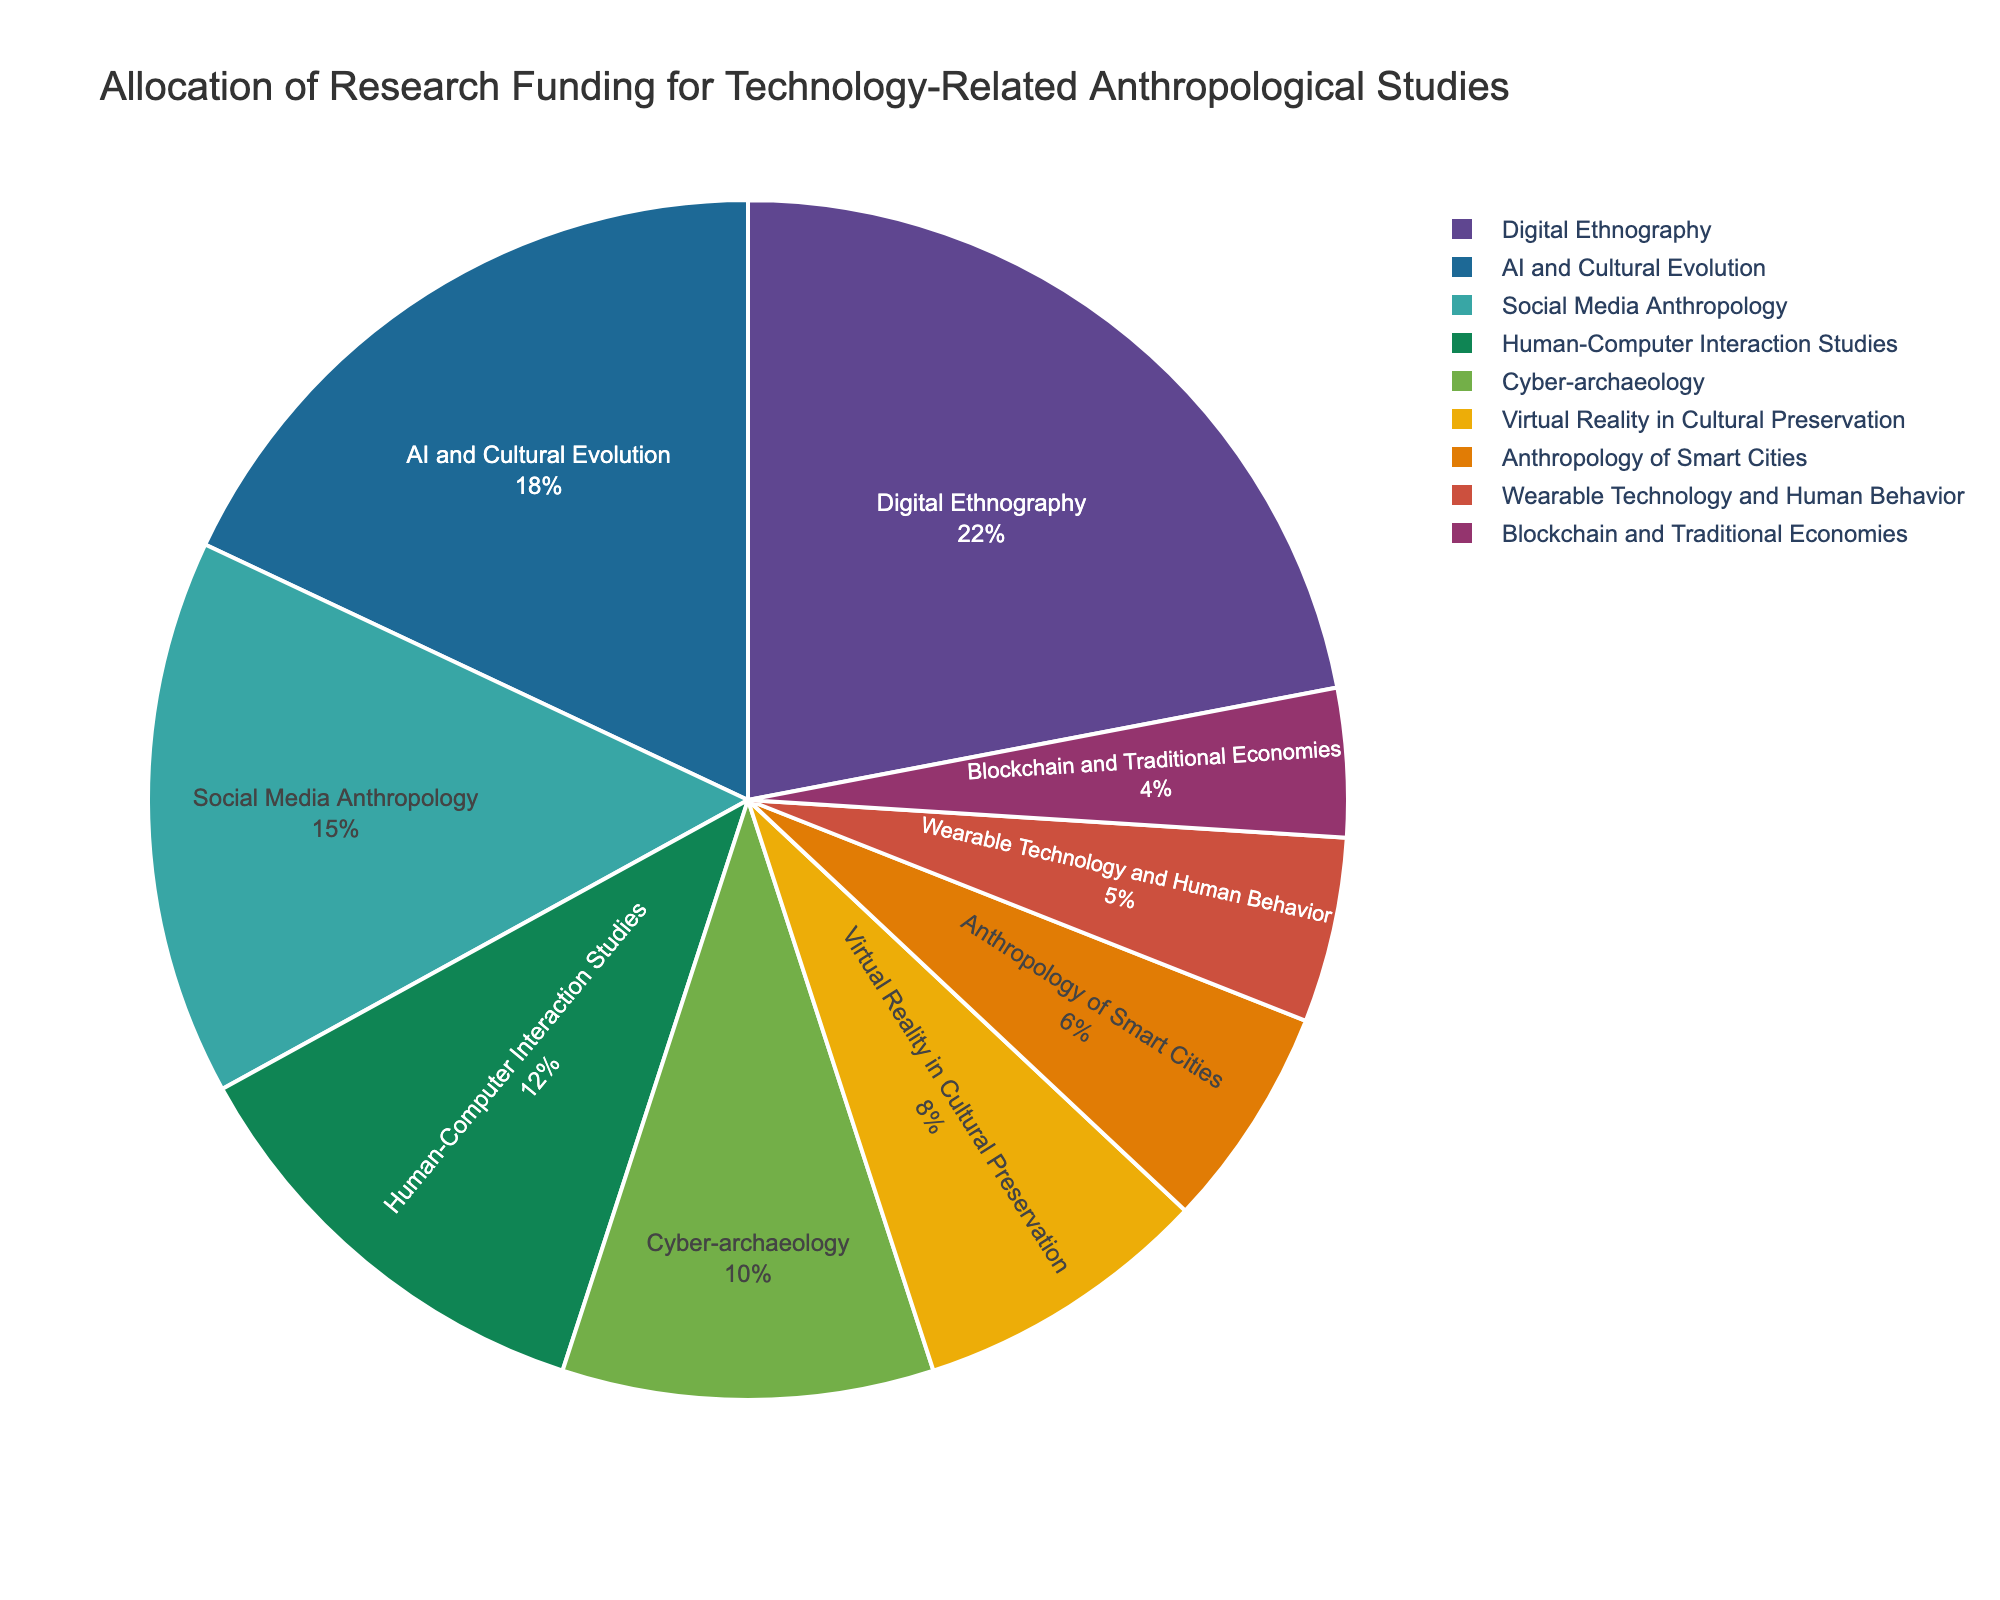What's the combined funding percentage for AI and Cultural Evolution, and Cyber-archaeology? First, identify the funding percentages for AI and Cultural Evolution (18%) and Cyber-archaeology (10%). Then sum these values: 18 + 10 = 28.
Answer: 28 Which research area received less funding, Wearable Technology and Human Behavior, or Blockchain and Traditional Economies? Wearable Technology and Human Behavior received 5%, while Blockchain and Traditional Economies received 4%. Since 4% is less than 5%, Blockchain and Traditional Economies received less funding.
Answer: Blockchain and Traditional Economies What is the difference in funding percentage between Social Media Anthropology and Human-Computer Interaction Studies? Social Media Anthropology received 15%, and Human-Computer Interaction Studies received 12%. The difference is 15 - 12 = 3.
Answer: 3 What is the average funding percentage for Digital Ethnography, Virtual Reality in Cultural Preservation, and Anthropology of Smart Cities? First, sum the percentages for these areas: Digital Ethnography (22%), Virtual Reality in Cultural Preservation (8%), and Anthropology of Smart Cities (6%). 22 + 8 + 6 = 36. Then, divide by the number of areas: 36 / 3 = 12.
Answer: 12 What are the top three research areas receiving the most funding? The percentages show that the top three areas are Digital Ethnography (22%), AI and Cultural Evolution (18%), and Social Media Anthropology (15%).
Answer: Digital Ethnography, AI and Cultural Evolution, Social Media Anthropology How much more funding does Digital Ethnography receive than Virtual Reality in Cultural Preservation? Digital Ethnography receives 22%, Virtual Reality in Cultural Preservation receives 8%. The difference is 22 - 8 = 14.
Answer: 14 Which research area receives the highest funding? From the chart, Digital Ethnography has the highest funding percentage at 22%.
Answer: Digital Ethnography Are any research areas allocated exactly 10% of the funding? Cyber-archaeology is allocated exactly 10% of the funding.
Answer: Cyber-archaeology 